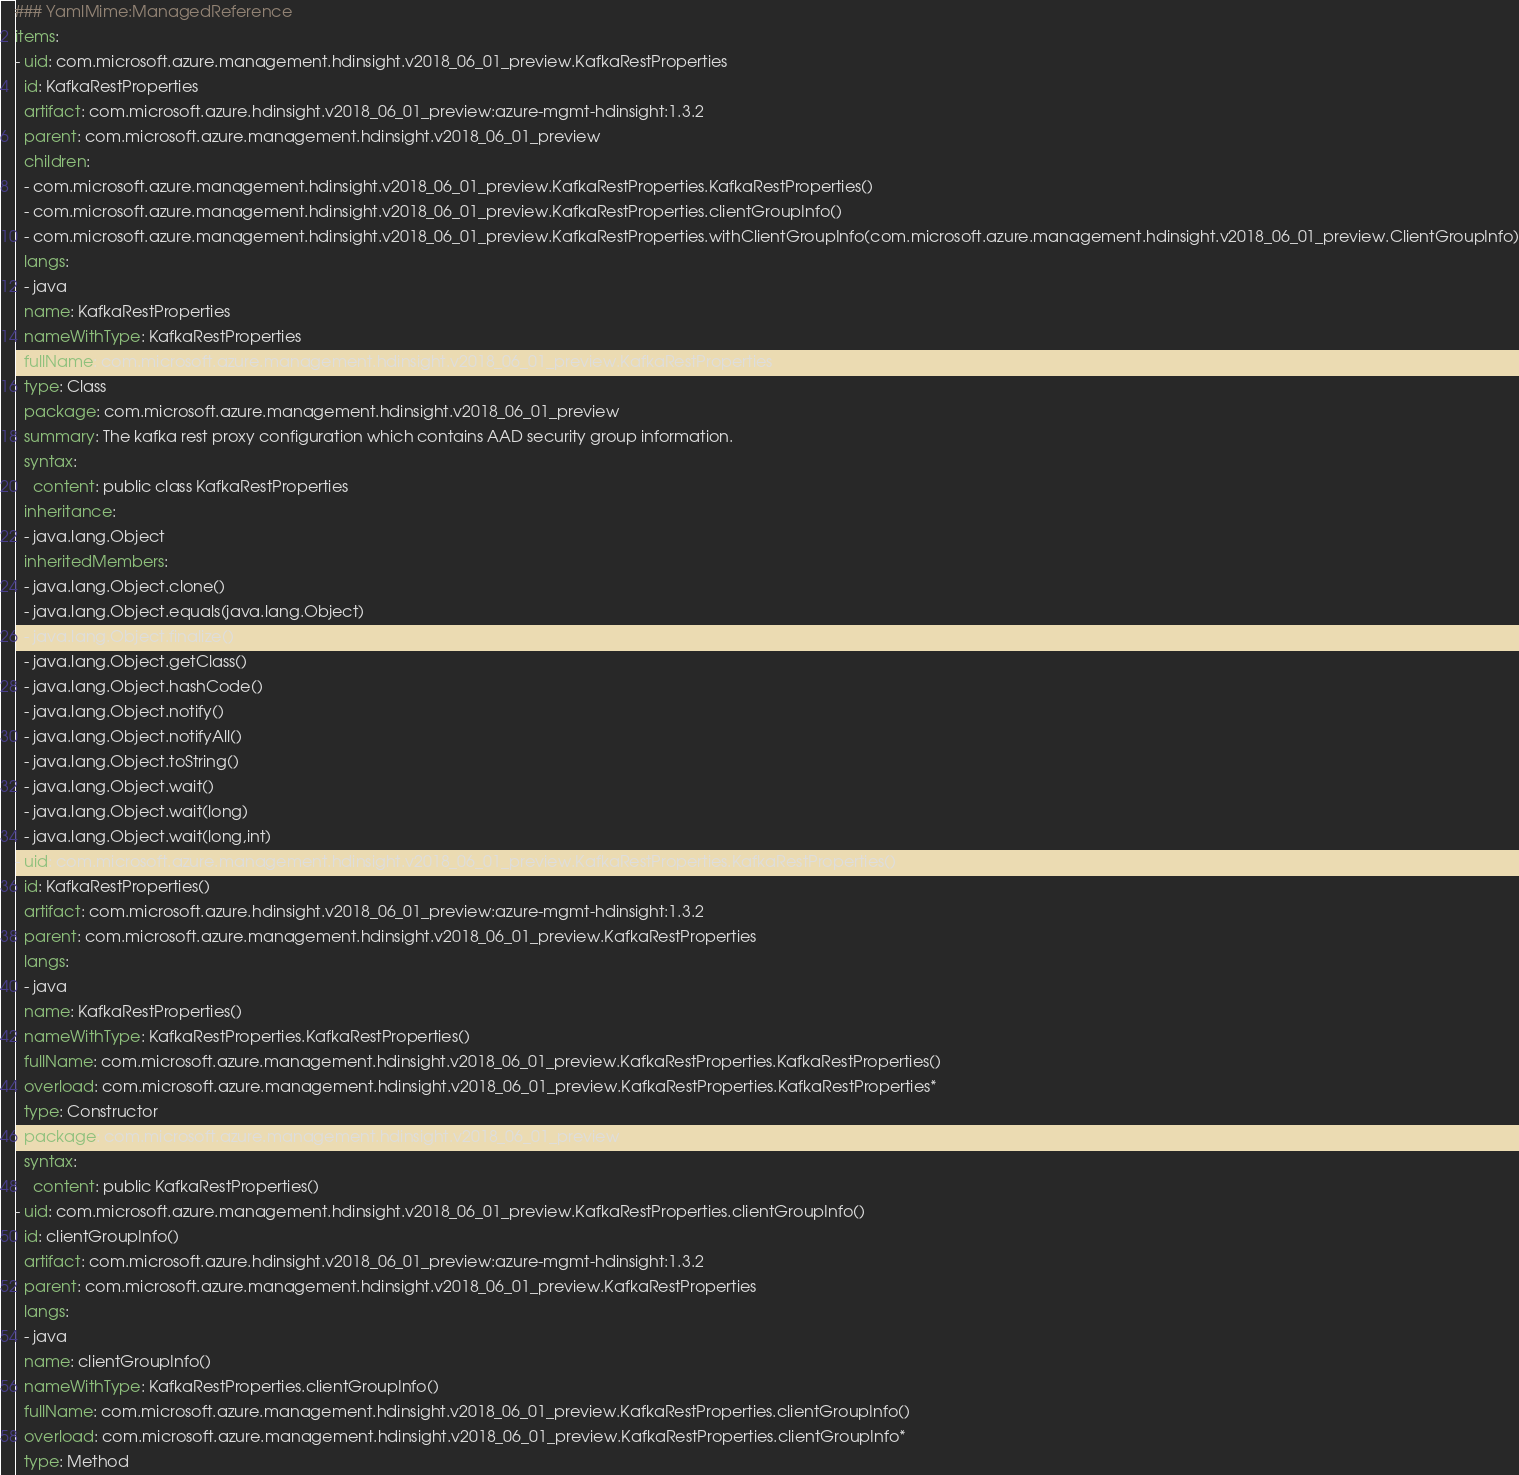Convert code to text. <code><loc_0><loc_0><loc_500><loc_500><_YAML_>### YamlMime:ManagedReference
items:
- uid: com.microsoft.azure.management.hdinsight.v2018_06_01_preview.KafkaRestProperties
  id: KafkaRestProperties
  artifact: com.microsoft.azure.hdinsight.v2018_06_01_preview:azure-mgmt-hdinsight:1.3.2
  parent: com.microsoft.azure.management.hdinsight.v2018_06_01_preview
  children:
  - com.microsoft.azure.management.hdinsight.v2018_06_01_preview.KafkaRestProperties.KafkaRestProperties()
  - com.microsoft.azure.management.hdinsight.v2018_06_01_preview.KafkaRestProperties.clientGroupInfo()
  - com.microsoft.azure.management.hdinsight.v2018_06_01_preview.KafkaRestProperties.withClientGroupInfo(com.microsoft.azure.management.hdinsight.v2018_06_01_preview.ClientGroupInfo)
  langs:
  - java
  name: KafkaRestProperties
  nameWithType: KafkaRestProperties
  fullName: com.microsoft.azure.management.hdinsight.v2018_06_01_preview.KafkaRestProperties
  type: Class
  package: com.microsoft.azure.management.hdinsight.v2018_06_01_preview
  summary: The kafka rest proxy configuration which contains AAD security group information.
  syntax:
    content: public class KafkaRestProperties
  inheritance:
  - java.lang.Object
  inheritedMembers:
  - java.lang.Object.clone()
  - java.lang.Object.equals(java.lang.Object)
  - java.lang.Object.finalize()
  - java.lang.Object.getClass()
  - java.lang.Object.hashCode()
  - java.lang.Object.notify()
  - java.lang.Object.notifyAll()
  - java.lang.Object.toString()
  - java.lang.Object.wait()
  - java.lang.Object.wait(long)
  - java.lang.Object.wait(long,int)
- uid: com.microsoft.azure.management.hdinsight.v2018_06_01_preview.KafkaRestProperties.KafkaRestProperties()
  id: KafkaRestProperties()
  artifact: com.microsoft.azure.hdinsight.v2018_06_01_preview:azure-mgmt-hdinsight:1.3.2
  parent: com.microsoft.azure.management.hdinsight.v2018_06_01_preview.KafkaRestProperties
  langs:
  - java
  name: KafkaRestProperties()
  nameWithType: KafkaRestProperties.KafkaRestProperties()
  fullName: com.microsoft.azure.management.hdinsight.v2018_06_01_preview.KafkaRestProperties.KafkaRestProperties()
  overload: com.microsoft.azure.management.hdinsight.v2018_06_01_preview.KafkaRestProperties.KafkaRestProperties*
  type: Constructor
  package: com.microsoft.azure.management.hdinsight.v2018_06_01_preview
  syntax:
    content: public KafkaRestProperties()
- uid: com.microsoft.azure.management.hdinsight.v2018_06_01_preview.KafkaRestProperties.clientGroupInfo()
  id: clientGroupInfo()
  artifact: com.microsoft.azure.hdinsight.v2018_06_01_preview:azure-mgmt-hdinsight:1.3.2
  parent: com.microsoft.azure.management.hdinsight.v2018_06_01_preview.KafkaRestProperties
  langs:
  - java
  name: clientGroupInfo()
  nameWithType: KafkaRestProperties.clientGroupInfo()
  fullName: com.microsoft.azure.management.hdinsight.v2018_06_01_preview.KafkaRestProperties.clientGroupInfo()
  overload: com.microsoft.azure.management.hdinsight.v2018_06_01_preview.KafkaRestProperties.clientGroupInfo*
  type: Method</code> 